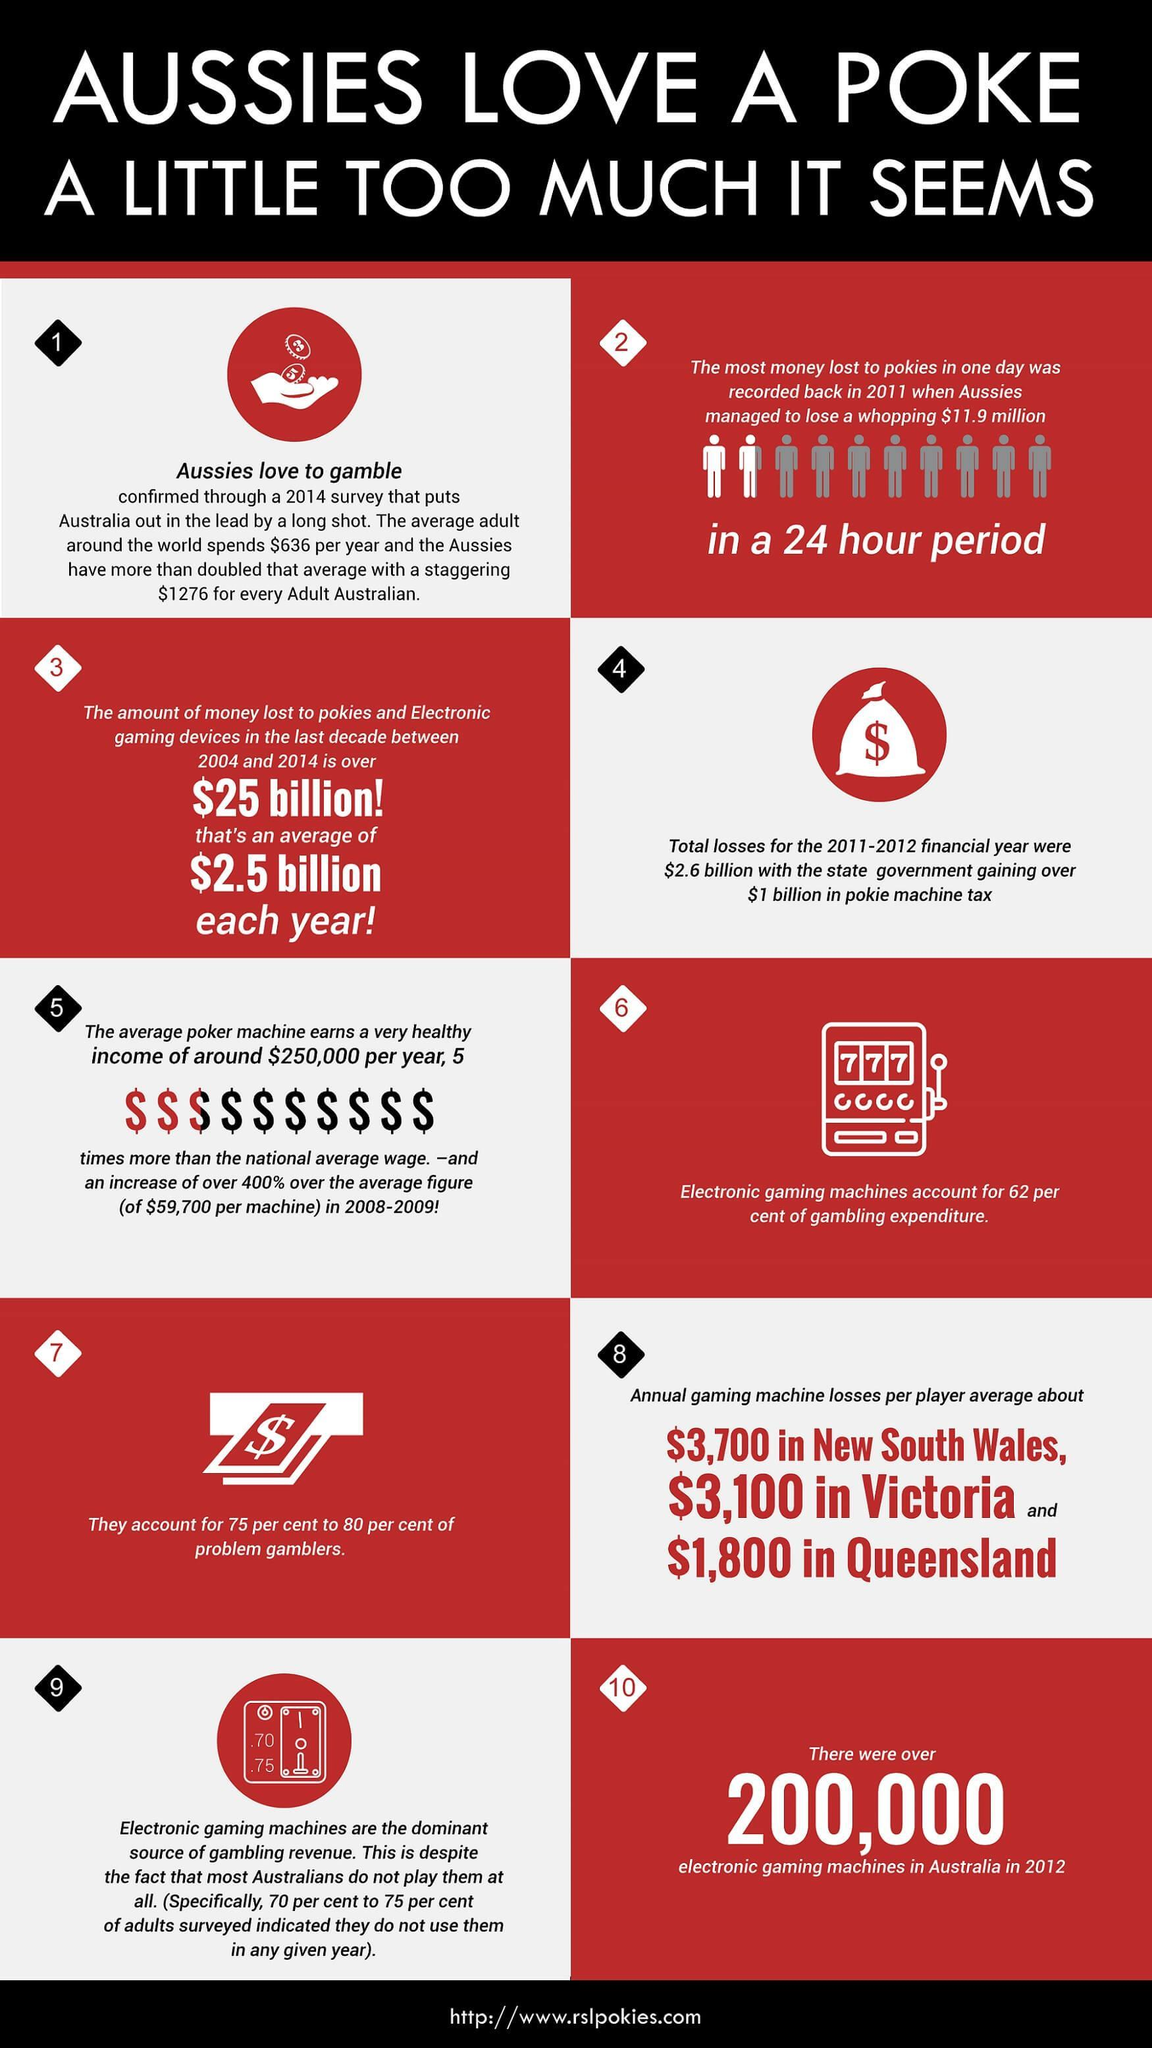what is the average money lost each year to pokies and electronic gaming devices between 2004 and 2014
Answer the question with a short phrase. $2.5 billion what was the highest amount lost in 24 hour period $11.9 million what is the total gaming machine losses in Victoria and Queensland 4900 what is the difference between the average earning per machine in 2008-2009 to 2014 190300 what is the game that is being discussed in the heading poke how is dollar sign represented $ 